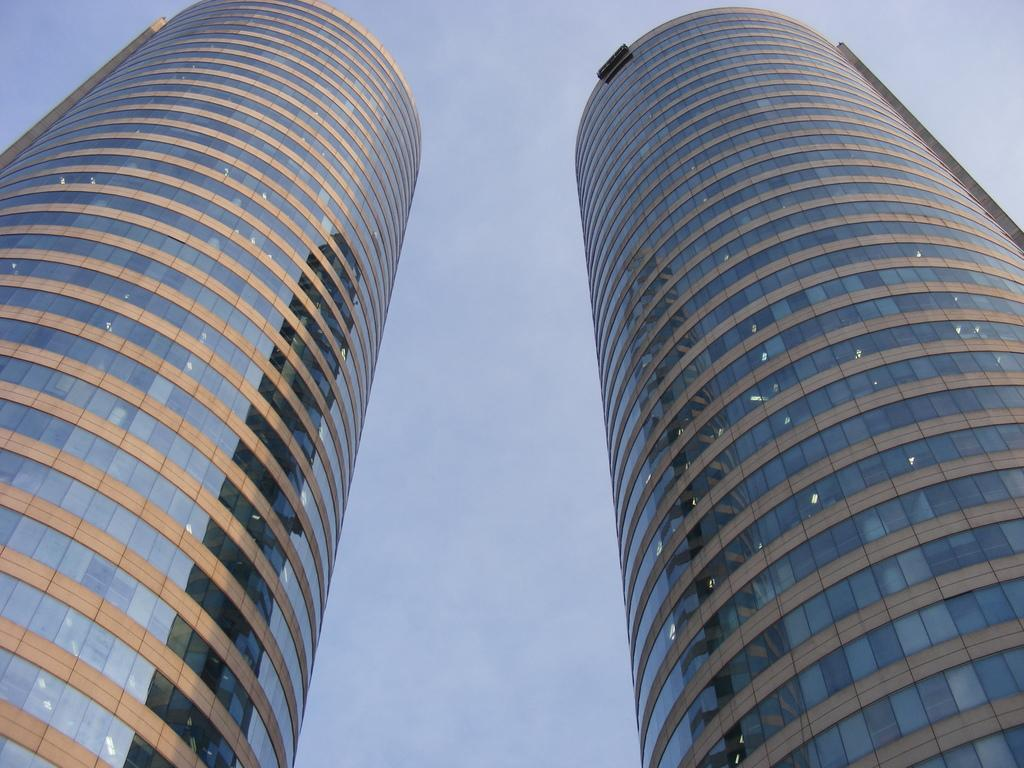What type of structures can be seen in the image? There are buildings in the image. What part of the natural environment is visible in the image? The sky is visible in the background of the image. How many cacti can be seen in the image? There are no cacti present in the image; it features buildings and the sky. What is the boy doing in the image? There is no boy present in the image. 